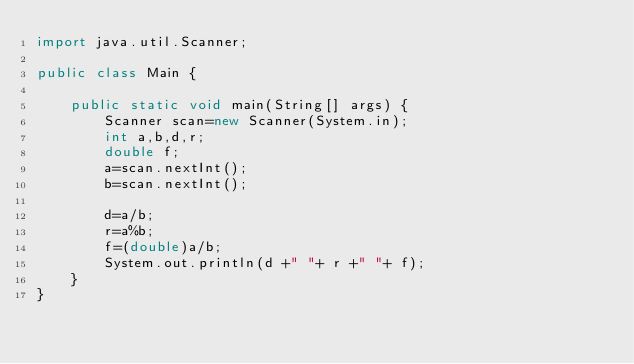<code> <loc_0><loc_0><loc_500><loc_500><_Java_>import java.util.Scanner;

public class Main {
   
    public static void main(String[] args) {
        Scanner scan=new Scanner(System.in);
        int a,b,d,r;
        double f;
        a=scan.nextInt();
        b=scan.nextInt();
        
        d=a/b;
        r=a%b;
        f=(double)a/b;
        System.out.println(d +" "+ r +" "+ f);
    }
}</code> 